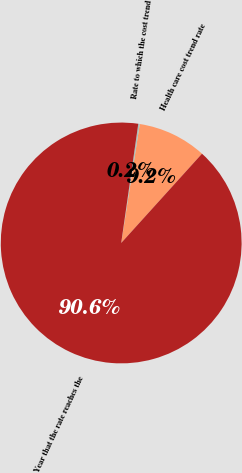<chart> <loc_0><loc_0><loc_500><loc_500><pie_chart><fcel>Health care cost trend rate<fcel>Rate to which the cost trend<fcel>Year that the rate reaches the<nl><fcel>9.24%<fcel>0.2%<fcel>90.56%<nl></chart> 